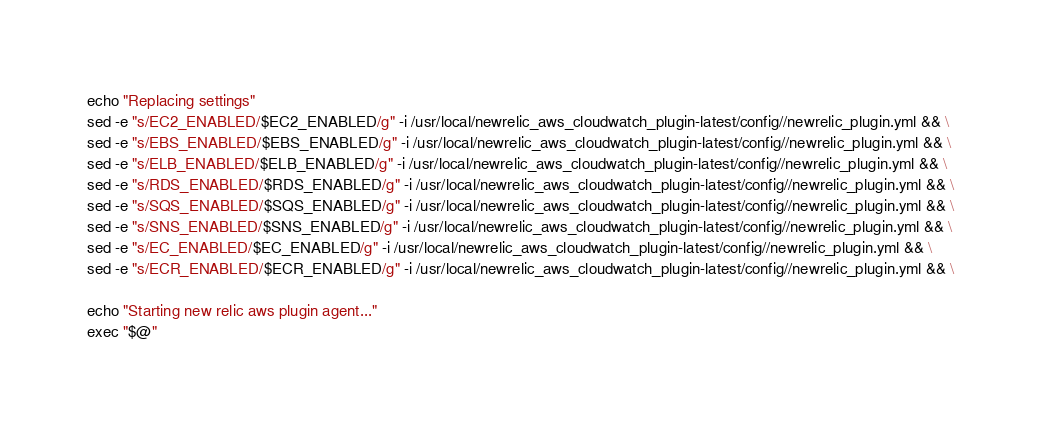Convert code to text. <code><loc_0><loc_0><loc_500><loc_500><_Bash_>echo "Replacing settings"
sed -e "s/EC2_ENABLED/$EC2_ENABLED/g" -i /usr/local/newrelic_aws_cloudwatch_plugin-latest/config//newrelic_plugin.yml && \
sed -e "s/EBS_ENABLED/$EBS_ENABLED/g" -i /usr/local/newrelic_aws_cloudwatch_plugin-latest/config//newrelic_plugin.yml && \
sed -e "s/ELB_ENABLED/$ELB_ENABLED/g" -i /usr/local/newrelic_aws_cloudwatch_plugin-latest/config//newrelic_plugin.yml && \
sed -e "s/RDS_ENABLED/$RDS_ENABLED/g" -i /usr/local/newrelic_aws_cloudwatch_plugin-latest/config//newrelic_plugin.yml && \
sed -e "s/SQS_ENABLED/$SQS_ENABLED/g" -i /usr/local/newrelic_aws_cloudwatch_plugin-latest/config//newrelic_plugin.yml && \
sed -e "s/SNS_ENABLED/$SNS_ENABLED/g" -i /usr/local/newrelic_aws_cloudwatch_plugin-latest/config//newrelic_plugin.yml && \
sed -e "s/EC_ENABLED/$EC_ENABLED/g" -i /usr/local/newrelic_aws_cloudwatch_plugin-latest/config//newrelic_plugin.yml && \
sed -e "s/ECR_ENABLED/$ECR_ENABLED/g" -i /usr/local/newrelic_aws_cloudwatch_plugin-latest/config//newrelic_plugin.yml && \

echo "Starting new relic aws plugin agent..."
exec "$@"
</code> 